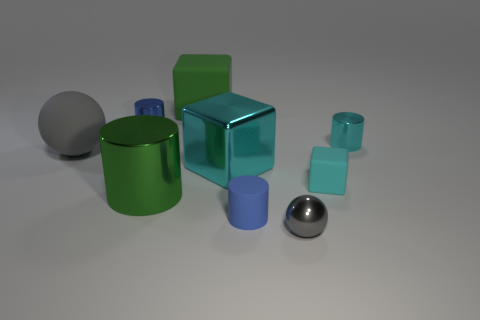Subtract all red cylinders. Subtract all red balls. How many cylinders are left? 4 Add 1 purple shiny balls. How many objects exist? 10 Subtract all blocks. How many objects are left? 6 Add 7 gray spheres. How many gray spheres are left? 9 Add 1 small cyan rubber blocks. How many small cyan rubber blocks exist? 2 Subtract 0 purple cylinders. How many objects are left? 9 Subtract all tiny cyan cylinders. Subtract all small shiny spheres. How many objects are left? 7 